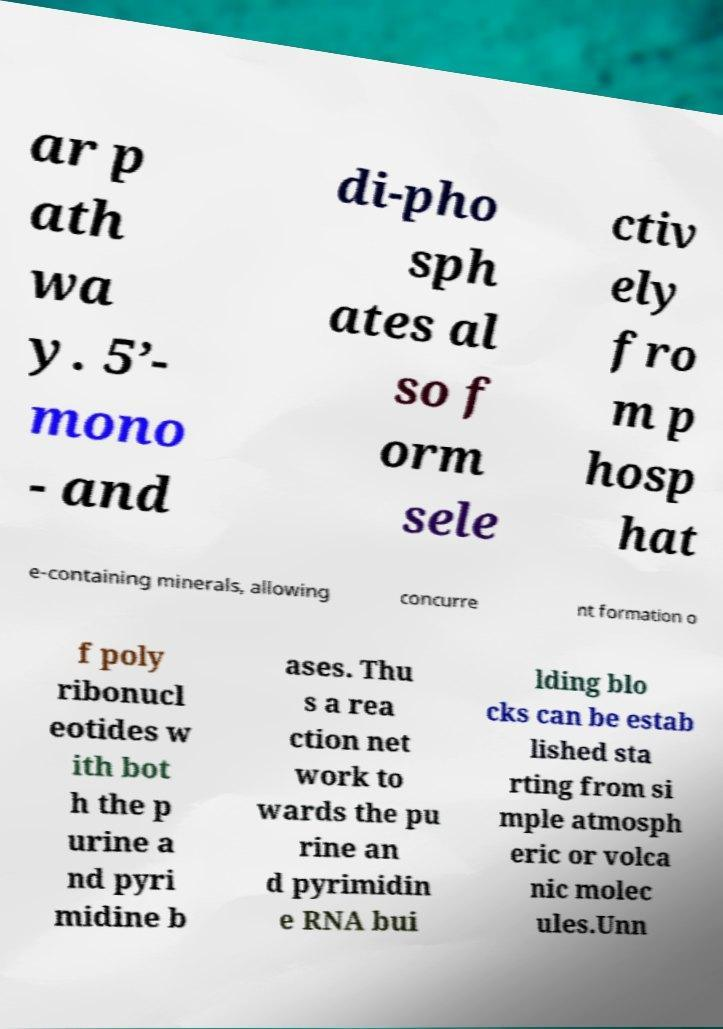What messages or text are displayed in this image? I need them in a readable, typed format. ar p ath wa y. 5’- mono - and di-pho sph ates al so f orm sele ctiv ely fro m p hosp hat e-containing minerals, allowing concurre nt formation o f poly ribonucl eotides w ith bot h the p urine a nd pyri midine b ases. Thu s a rea ction net work to wards the pu rine an d pyrimidin e RNA bui lding blo cks can be estab lished sta rting from si mple atmosph eric or volca nic molec ules.Unn 